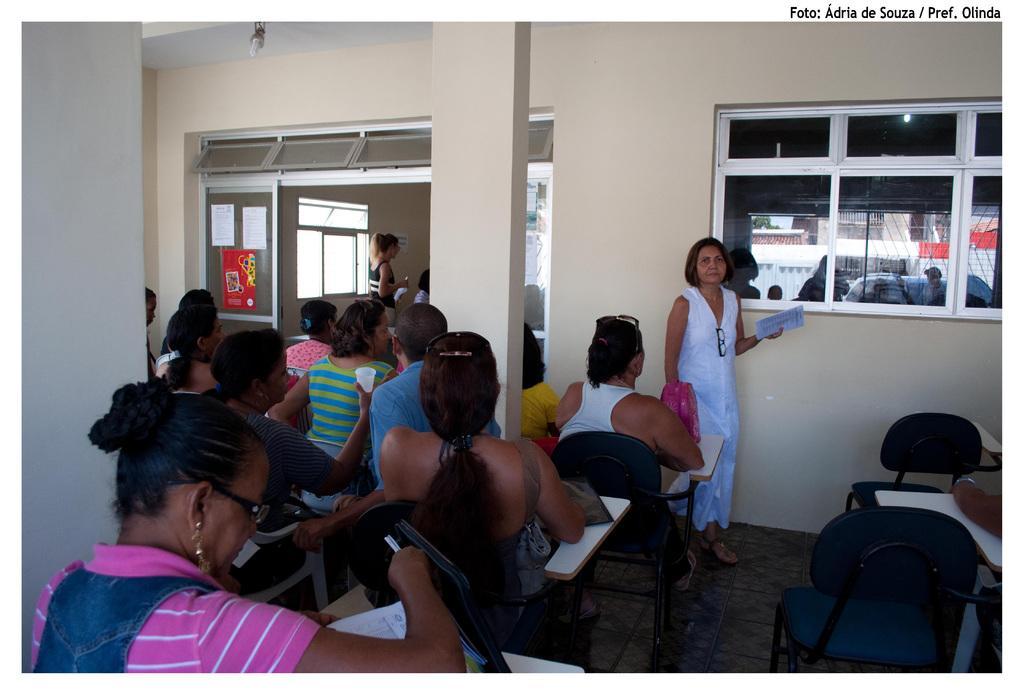Describe this image in one or two sentences. This image looks like it is clicked inside a room. It looks like a classroom. There are many people sitting in the chairs and listening to a woman. In the middle there is a woman, standing and holding a paper, in her hands. In the background , there is a wall, window and pillar. 